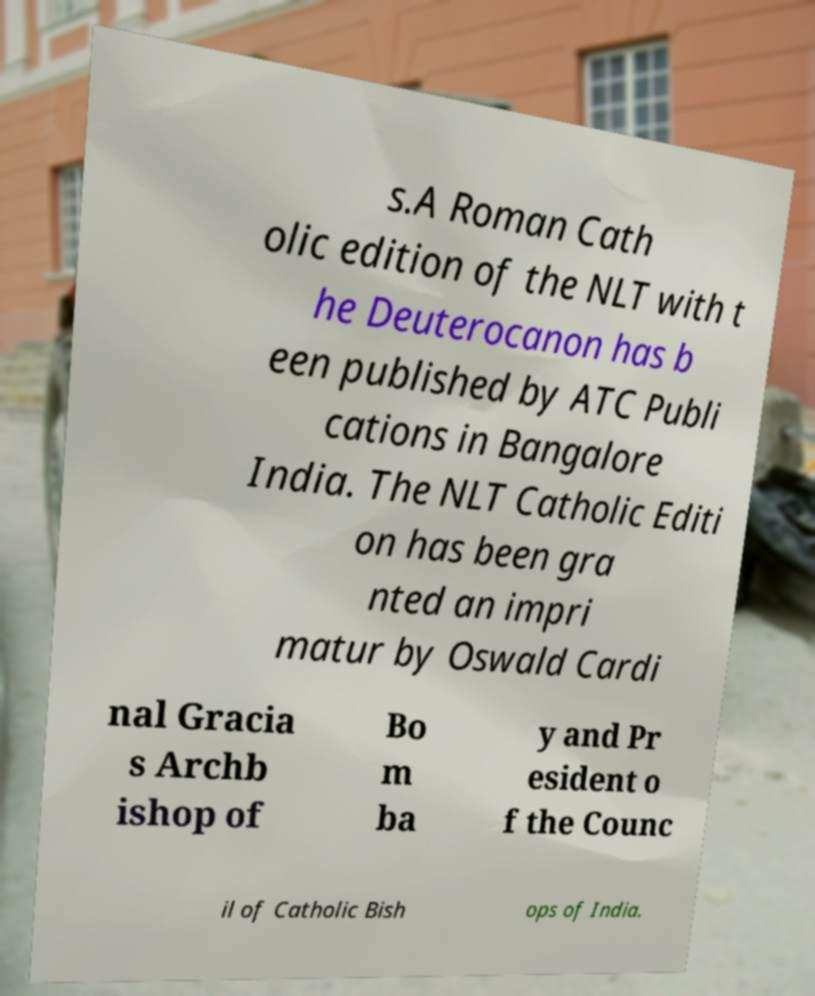Please identify and transcribe the text found in this image. s.A Roman Cath olic edition of the NLT with t he Deuterocanon has b een published by ATC Publi cations in Bangalore India. The NLT Catholic Editi on has been gra nted an impri matur by Oswald Cardi nal Gracia s Archb ishop of Bo m ba y and Pr esident o f the Counc il of Catholic Bish ops of India. 